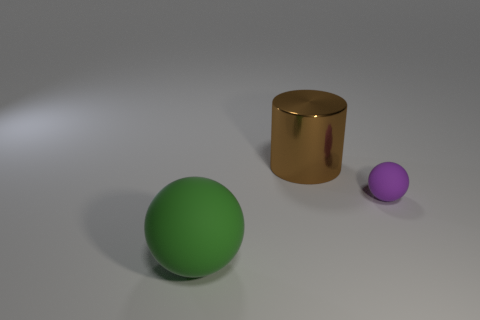There is a rubber ball to the left of the small ball; what is its color?
Your answer should be compact. Green. There is a object that is right of the large green sphere and on the left side of the purple rubber thing; what is its shape?
Your response must be concise. Cylinder. How many other big green things are the same shape as the large green object?
Provide a short and direct response. 0. How many rubber objects are there?
Offer a terse response. 2. What is the size of the object that is to the left of the small purple matte ball and in front of the cylinder?
Your answer should be very brief. Large. The brown thing that is the same size as the green rubber sphere is what shape?
Offer a terse response. Cylinder. Are there any purple things that are to the left of the sphere that is right of the big matte object?
Ensure brevity in your answer.  No. What color is the other matte thing that is the same shape as the green object?
Make the answer very short. Purple. There is a matte thing in front of the small object; is it the same color as the small thing?
Your answer should be compact. No. How many objects are things to the right of the cylinder or big yellow rubber cubes?
Provide a succinct answer. 1. 